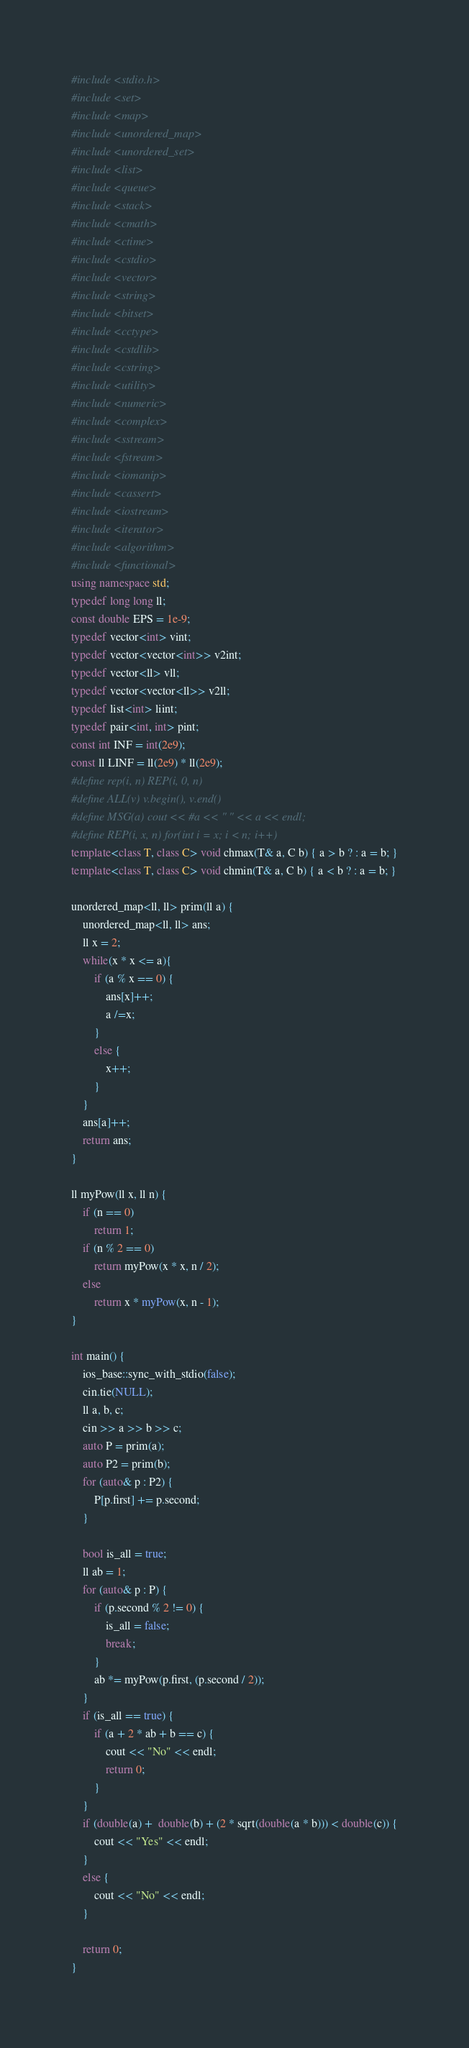<code> <loc_0><loc_0><loc_500><loc_500><_C++_>#include <stdio.h>
#include <set>
#include <map>
#include <unordered_map>
#include <unordered_set>
#include <list>
#include <queue>
#include <stack>
#include <cmath>
#include <ctime>
#include <cstdio>
#include <vector>
#include <string>
#include <bitset>
#include <cctype>
#include <cstdlib>
#include <cstring>
#include <utility>
#include <numeric>
#include <complex>
#include <sstream>
#include <fstream>
#include <iomanip>
#include <cassert>
#include <iostream>
#include <iterator>
#include <algorithm>
#include <functional>
using namespace std;
typedef long long ll;
const double EPS = 1e-9;
typedef vector<int> vint;
typedef vector<vector<int>> v2int;
typedef vector<ll> vll;
typedef vector<vector<ll>> v2ll;
typedef list<int> liint;
typedef pair<int, int> pint;
const int INF = int(2e9);
const ll LINF = ll(2e9) * ll(2e9);
#define rep(i, n) REP(i, 0, n)
#define ALL(v) v.begin(), v.end()
#define MSG(a) cout << #a << " " << a << endl;
#define REP(i, x, n) for(int i = x; i < n; i++)
template<class T, class C> void chmax(T& a, C b) { a > b ? : a = b; }
template<class T, class C> void chmin(T& a, C b) { a < b ? : a = b; }

unordered_map<ll, ll> prim(ll a) {
    unordered_map<ll, ll> ans;
    ll x = 2;
    while(x * x <= a){
        if (a % x == 0) {
            ans[x]++;
            a /=x;
        }
        else {
            x++;
        }
    }
    ans[a]++;
    return ans;
}

ll myPow(ll x, ll n) {
    if (n == 0)
        return 1;
    if (n % 2 == 0)
        return myPow(x * x, n / 2);
    else
        return x * myPow(x, n - 1);
}

int main() {
    ios_base::sync_with_stdio(false);
    cin.tie(NULL);
    ll a, b, c;
    cin >> a >> b >> c;
    auto P = prim(a);
    auto P2 = prim(b);
    for (auto& p : P2) {
        P[p.first] += p.second;
    }

    bool is_all = true;
    ll ab = 1;
    for (auto& p : P) {
        if (p.second % 2 != 0) {
            is_all = false;
            break;
        }
        ab *= myPow(p.first, (p.second / 2));
    }
    if (is_all == true) {
        if (a + 2 * ab + b == c) {
            cout << "No" << endl;
            return 0;
        }
    }
    if (double(a) +  double(b) + (2 * sqrt(double(a * b))) < double(c)) {
        cout << "Yes" << endl;
    }
    else {
        cout << "No" << endl;
    }

    return 0;
}</code> 